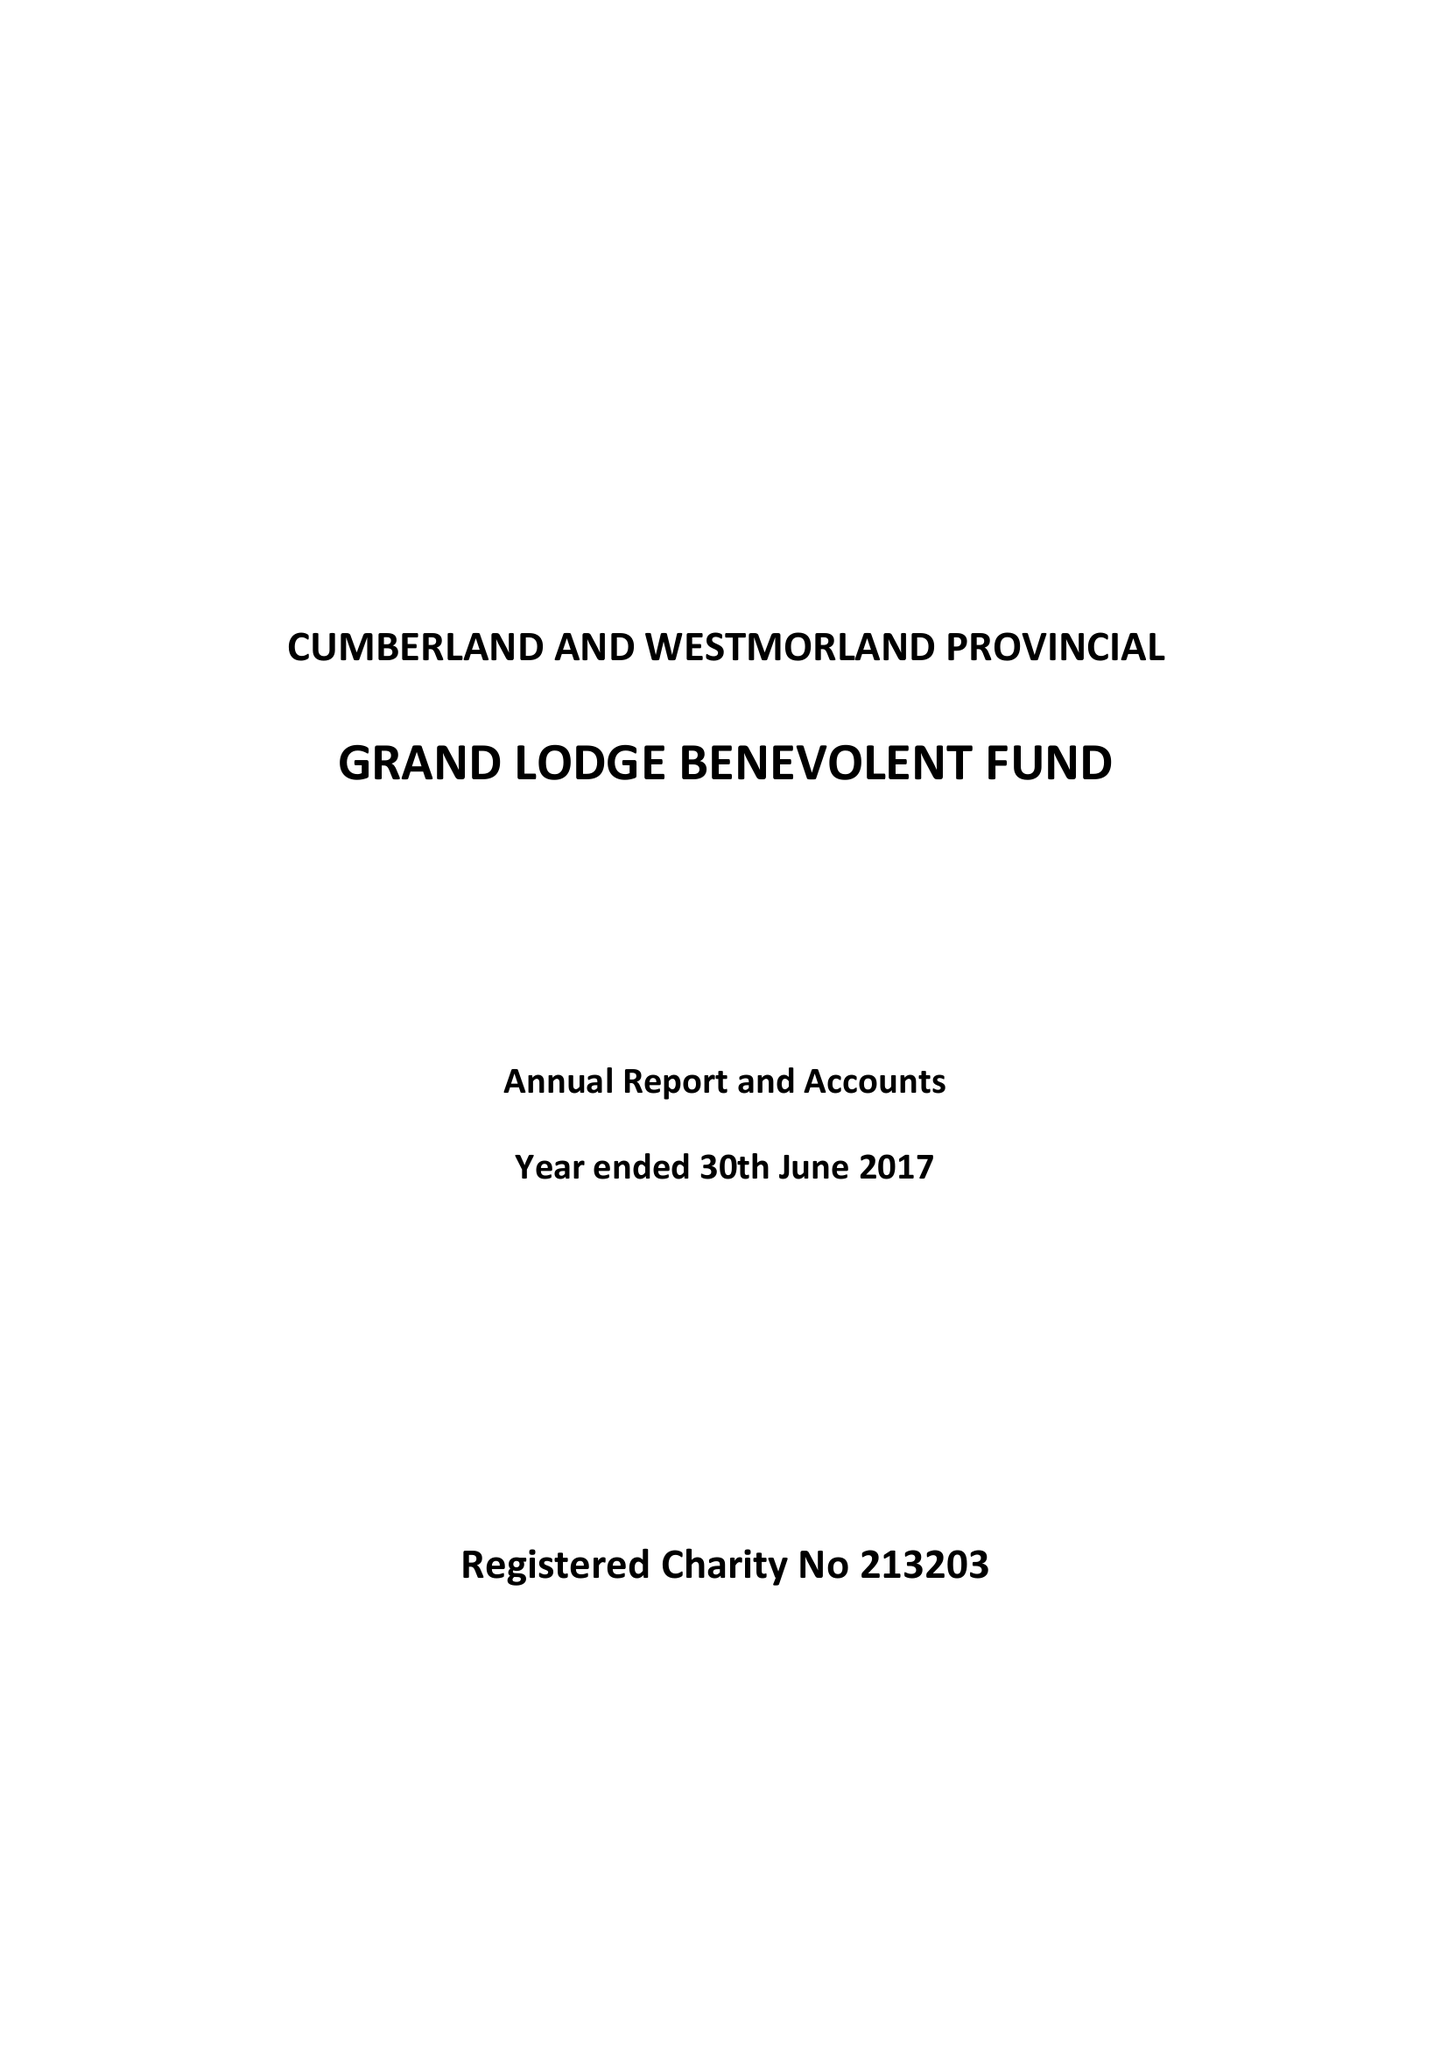What is the value for the income_annually_in_british_pounds?
Answer the question using a single word or phrase. 74955.00 